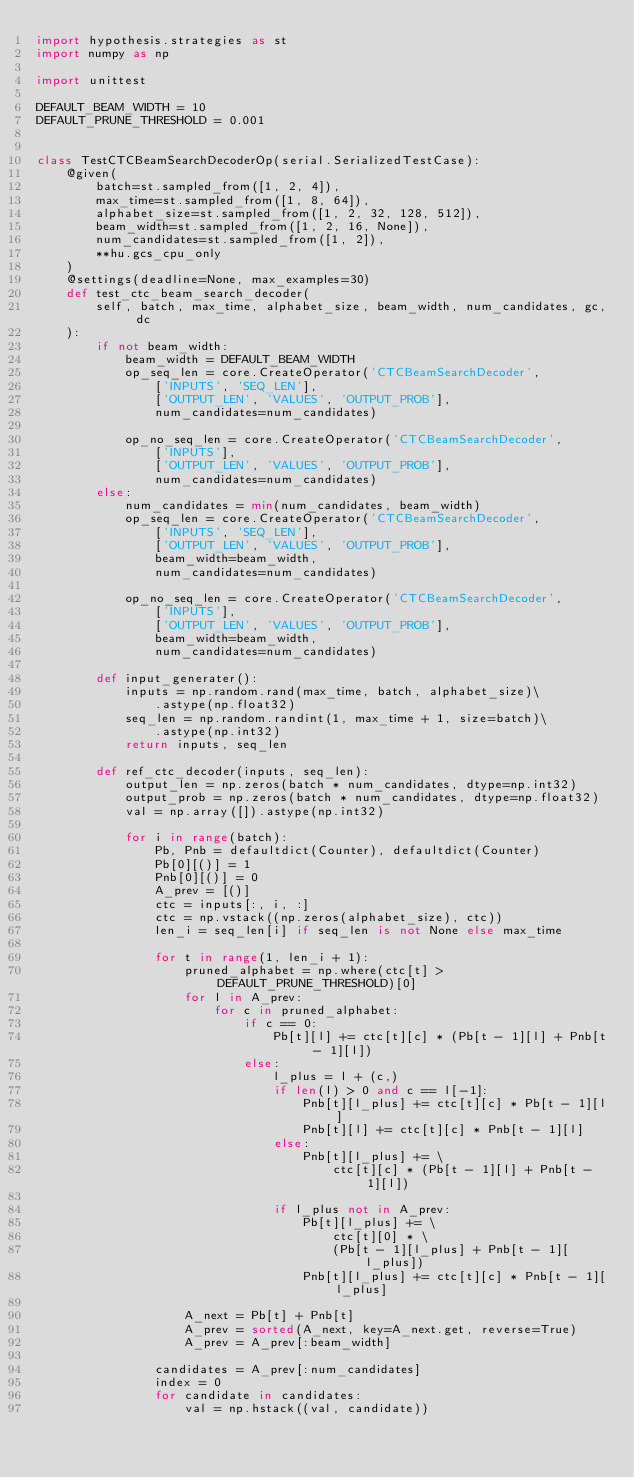<code> <loc_0><loc_0><loc_500><loc_500><_Python_>import hypothesis.strategies as st
import numpy as np

import unittest

DEFAULT_BEAM_WIDTH = 10
DEFAULT_PRUNE_THRESHOLD = 0.001


class TestCTCBeamSearchDecoderOp(serial.SerializedTestCase):
    @given(
        batch=st.sampled_from([1, 2, 4]),
        max_time=st.sampled_from([1, 8, 64]),
        alphabet_size=st.sampled_from([1, 2, 32, 128, 512]),
        beam_width=st.sampled_from([1, 2, 16, None]),
        num_candidates=st.sampled_from([1, 2]),
        **hu.gcs_cpu_only
    )
    @settings(deadline=None, max_examples=30)
    def test_ctc_beam_search_decoder(
        self, batch, max_time, alphabet_size, beam_width, num_candidates, gc, dc
    ):
        if not beam_width:
            beam_width = DEFAULT_BEAM_WIDTH
            op_seq_len = core.CreateOperator('CTCBeamSearchDecoder',
                ['INPUTS', 'SEQ_LEN'],
                ['OUTPUT_LEN', 'VALUES', 'OUTPUT_PROB'],
                num_candidates=num_candidates)

            op_no_seq_len = core.CreateOperator('CTCBeamSearchDecoder',
                ['INPUTS'],
                ['OUTPUT_LEN', 'VALUES', 'OUTPUT_PROB'],
                num_candidates=num_candidates)
        else:
            num_candidates = min(num_candidates, beam_width)
            op_seq_len = core.CreateOperator('CTCBeamSearchDecoder',
                ['INPUTS', 'SEQ_LEN'],
                ['OUTPUT_LEN', 'VALUES', 'OUTPUT_PROB'],
                beam_width=beam_width,
                num_candidates=num_candidates)

            op_no_seq_len = core.CreateOperator('CTCBeamSearchDecoder',
                ['INPUTS'],
                ['OUTPUT_LEN', 'VALUES', 'OUTPUT_PROB'],
                beam_width=beam_width,
                num_candidates=num_candidates)

        def input_generater():
            inputs = np.random.rand(max_time, batch, alphabet_size)\
                .astype(np.float32)
            seq_len = np.random.randint(1, max_time + 1, size=batch)\
                .astype(np.int32)
            return inputs, seq_len

        def ref_ctc_decoder(inputs, seq_len):
            output_len = np.zeros(batch * num_candidates, dtype=np.int32)
            output_prob = np.zeros(batch * num_candidates, dtype=np.float32)
            val = np.array([]).astype(np.int32)

            for i in range(batch):
                Pb, Pnb = defaultdict(Counter), defaultdict(Counter)
                Pb[0][()] = 1
                Pnb[0][()] = 0
                A_prev = [()]
                ctc = inputs[:, i, :]
                ctc = np.vstack((np.zeros(alphabet_size), ctc))
                len_i = seq_len[i] if seq_len is not None else max_time

                for t in range(1, len_i + 1):
                    pruned_alphabet = np.where(ctc[t] > DEFAULT_PRUNE_THRESHOLD)[0]
                    for l in A_prev:
                        for c in pruned_alphabet:
                            if c == 0:
                                Pb[t][l] += ctc[t][c] * (Pb[t - 1][l] + Pnb[t - 1][l])
                            else:
                                l_plus = l + (c,)
                                if len(l) > 0 and c == l[-1]:
                                    Pnb[t][l_plus] += ctc[t][c] * Pb[t - 1][l]
                                    Pnb[t][l] += ctc[t][c] * Pnb[t - 1][l]
                                else:
                                    Pnb[t][l_plus] += \
                                        ctc[t][c] * (Pb[t - 1][l] + Pnb[t - 1][l])

                                if l_plus not in A_prev:
                                    Pb[t][l_plus] += \
                                        ctc[t][0] * \
                                        (Pb[t - 1][l_plus] + Pnb[t - 1][l_plus])
                                    Pnb[t][l_plus] += ctc[t][c] * Pnb[t - 1][l_plus]

                    A_next = Pb[t] + Pnb[t]
                    A_prev = sorted(A_next, key=A_next.get, reverse=True)
                    A_prev = A_prev[:beam_width]

                candidates = A_prev[:num_candidates]
                index = 0
                for candidate in candidates:
                    val = np.hstack((val, candidate))</code> 